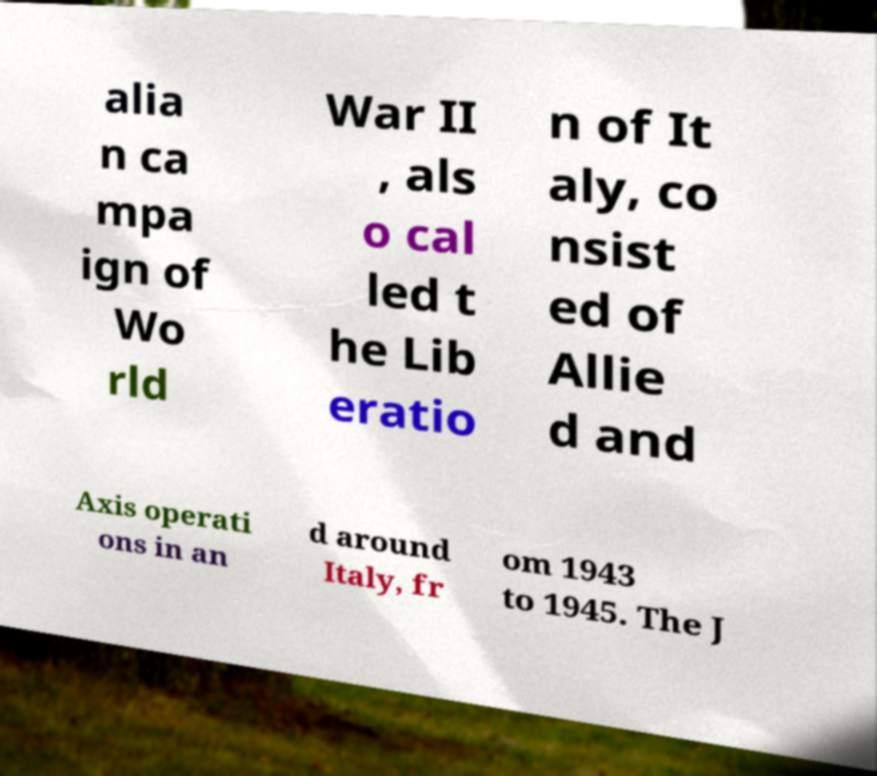Please read and relay the text visible in this image. What does it say? alia n ca mpa ign of Wo rld War II , als o cal led t he Lib eratio n of It aly, co nsist ed of Allie d and Axis operati ons in an d around Italy, fr om 1943 to 1945. The J 